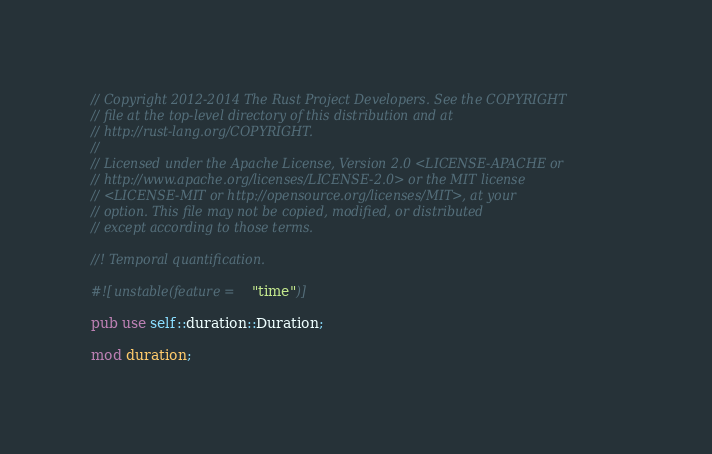Convert code to text. <code><loc_0><loc_0><loc_500><loc_500><_Rust_>// Copyright 2012-2014 The Rust Project Developers. See the COPYRIGHT
// file at the top-level directory of this distribution and at
// http://rust-lang.org/COPYRIGHT.
//
// Licensed under the Apache License, Version 2.0 <LICENSE-APACHE or
// http://www.apache.org/licenses/LICENSE-2.0> or the MIT license
// <LICENSE-MIT or http://opensource.org/licenses/MIT>, at your
// option. This file may not be copied, modified, or distributed
// except according to those terms.

//! Temporal quantification.

#![unstable(feature = "time")]

pub use self::duration::Duration;

mod duration;
</code> 